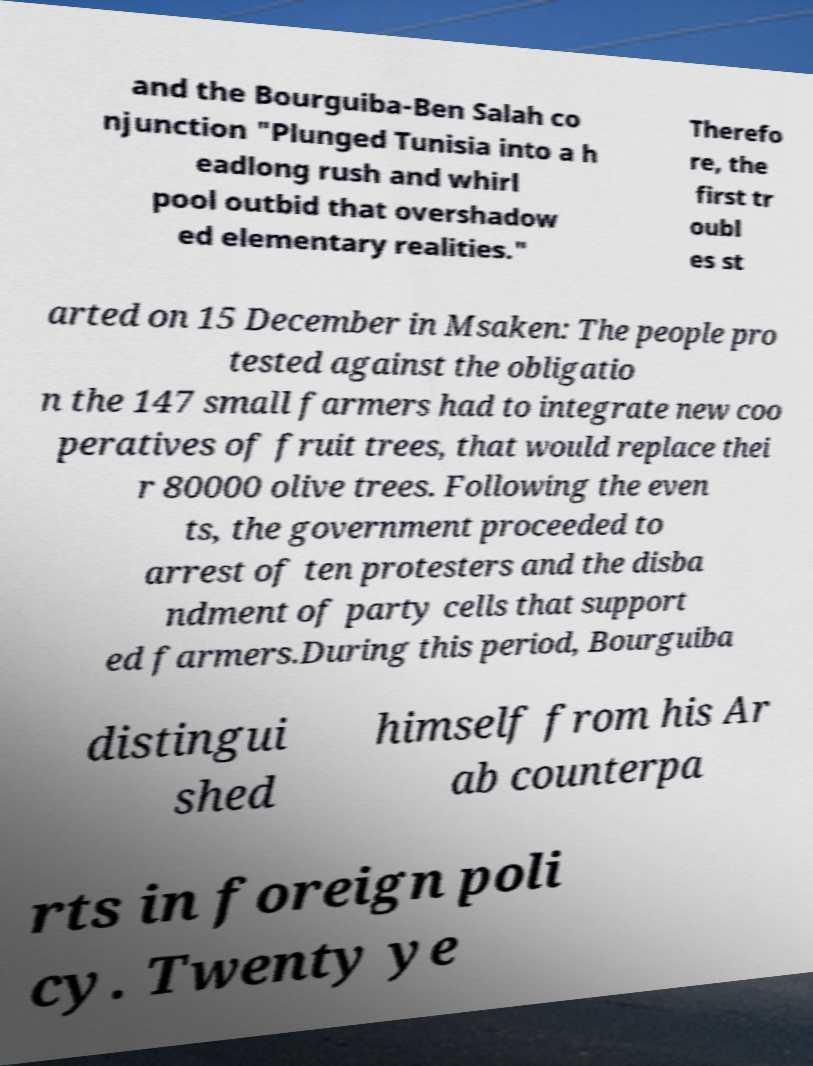Please identify and transcribe the text found in this image. and the Bourguiba-Ben Salah co njunction "Plunged Tunisia into a h eadlong rush and whirl pool outbid that overshadow ed elementary realities." Therefo re, the first tr oubl es st arted on 15 December in Msaken: The people pro tested against the obligatio n the 147 small farmers had to integrate new coo peratives of fruit trees, that would replace thei r 80000 olive trees. Following the even ts, the government proceeded to arrest of ten protesters and the disba ndment of party cells that support ed farmers.During this period, Bourguiba distingui shed himself from his Ar ab counterpa rts in foreign poli cy. Twenty ye 